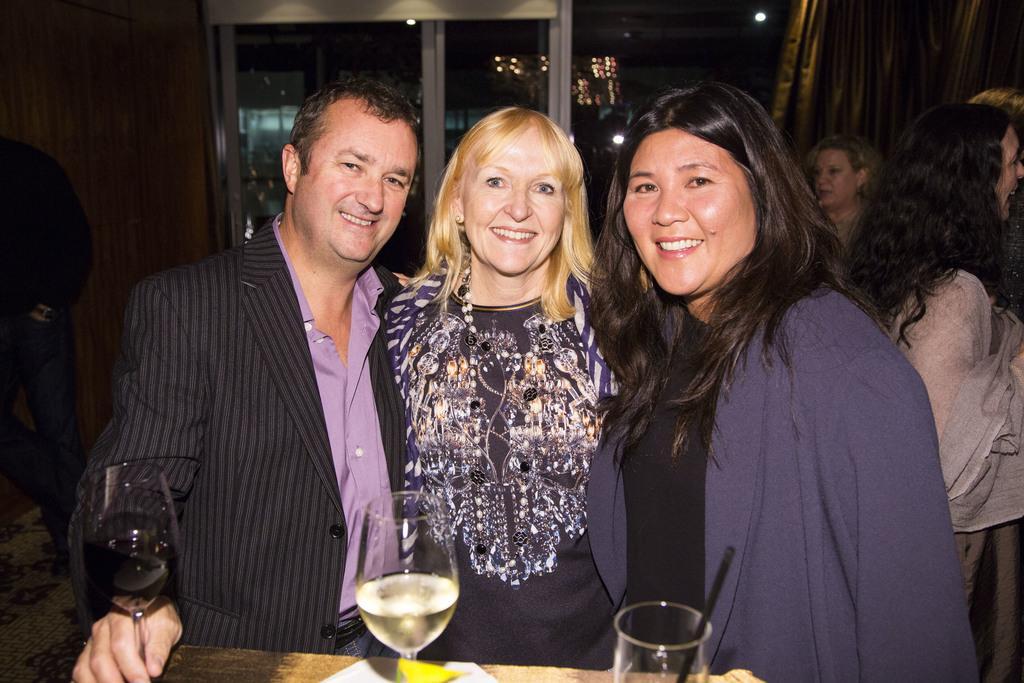Can you describe this image briefly? in this picture we can see a man standing and he is wearing a suit a holding a wine glass in his hand, and at beside a woman is standing and she is smiling, and beside her a woman is standing and smiling ,and in front there is the table and glass on it, and at back there is the window, and here there are lights. 